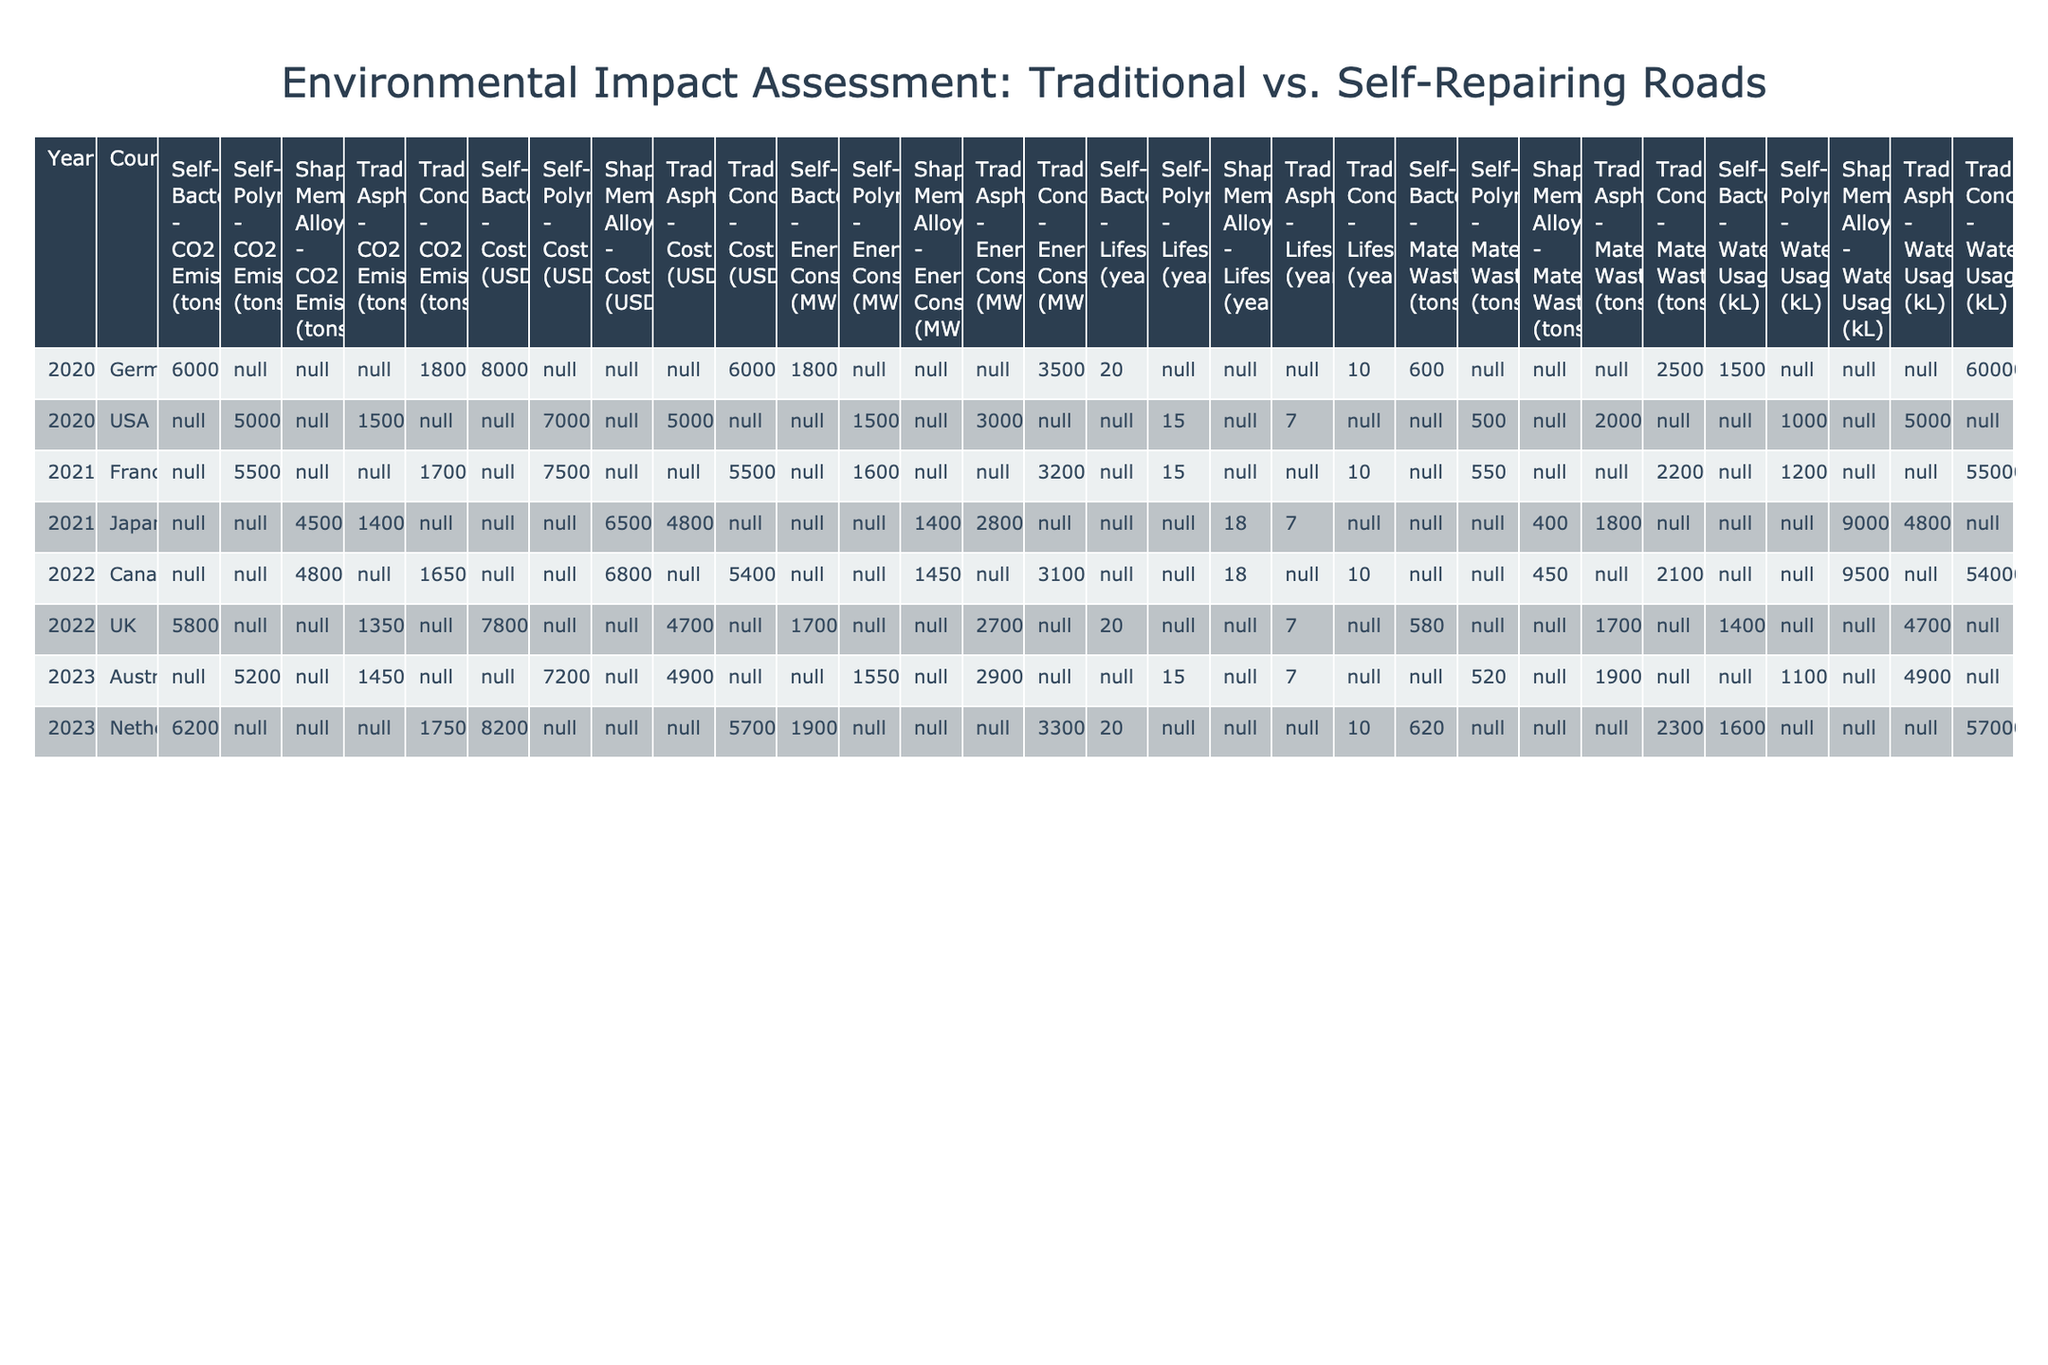What are the CO2 emissions from traditional asphalt maintenance in Australia in 2023? The table shows the row corresponding to Australia and the year 2023 under the "Traditional Asphalt" maintenance type, which lists the CO2 emissions as 14500 tons.
Answer: 14500 tons Which material waste is lower: traditional asphalt in the USA or self-repairing polymer in the USA? Traditional asphalt in the USA has a material waste of 2000 tons, while self-repairing polymer has a material waste of 500 tons. Since 500 tons is lower than 2000 tons, self-repairing polymer has less material waste.
Answer: Self-repairing polymer What is the average lifespan of self-repairing technologies across all countries and years provided? Summing the lifespans of self-repairing technologies gives (15 + 20 + 15 + 20) = 70. There are 4 data points, so the average is 70 / 4 = 17.5 years.
Answer: 17.5 years Is the energy consumption of self-healing bacteria higher in Germany or the Netherlands? The self-healing bacteria in Germany has an energy consumption of 18000 MWh, while in the Netherlands it is 19000 MWh. Since 19000 MWh is greater than 18000 MWh, the energy consumption is higher in the Netherlands.
Answer: Yes, it is higher in the Netherlands Which maintenance type has the highest water usage in Canada and what is that value? The traditional concrete maintenance type in Canada shows water usage of 54000 kL, which is greater than the 9500 kL from shape memory alloy. Therefore, traditional concrete has the highest water usage.
Answer: Traditional concrete, 54000 kL What is the difference in cost between self-repairing polymer and traditional concrete in France in 2021? The cost of self-repairing polymer in France for 2021 is 7500000 USD, and traditional concrete costs 5500000 USD. The difference in cost is 7500000 - 5500000 = 2000000 USD.
Answer: 2000000 USD Is there any year where self-repairing polymer technology has a higher CO2 emission than traditional asphalt? Looking at the data, self-repairing polymer emissions are 5000 tons in 2020 in the USA, compared to 15000 tons for traditional asphalt. In 2023, self-repairing polymer emits 5200 tons against 14500 tons for traditional asphalt. Thus, self-repairing polymer never has higher CO2 emissions than traditional asphalt in the years provided.
Answer: No What cumulative water usage of self-repairing technologies can be determined across all years and countries? The water usage in the provided data for self-repairing technologies sums up to 10000 (USA) + 15000 (Germany) + 14000 (UK) + 11000 (Australia) = 50000 kL.
Answer: 50000 kL 